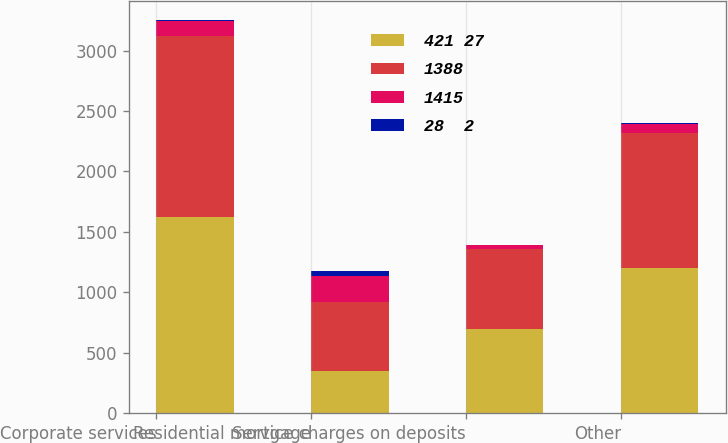Convert chart to OTSL. <chart><loc_0><loc_0><loc_500><loc_500><stacked_bar_chart><ecel><fcel>Corporate services<fcel>Residential mortgage<fcel>Service charges on deposits<fcel>Other<nl><fcel>421 27<fcel>1621<fcel>350<fcel>695<fcel>1198<nl><fcel>1388<fcel>1504<fcel>567<fcel>667<fcel>1124<nl><fcel>1415<fcel>117<fcel>217<fcel>28<fcel>74<nl><fcel>28  2<fcel>8<fcel>38<fcel>4<fcel>7<nl></chart> 